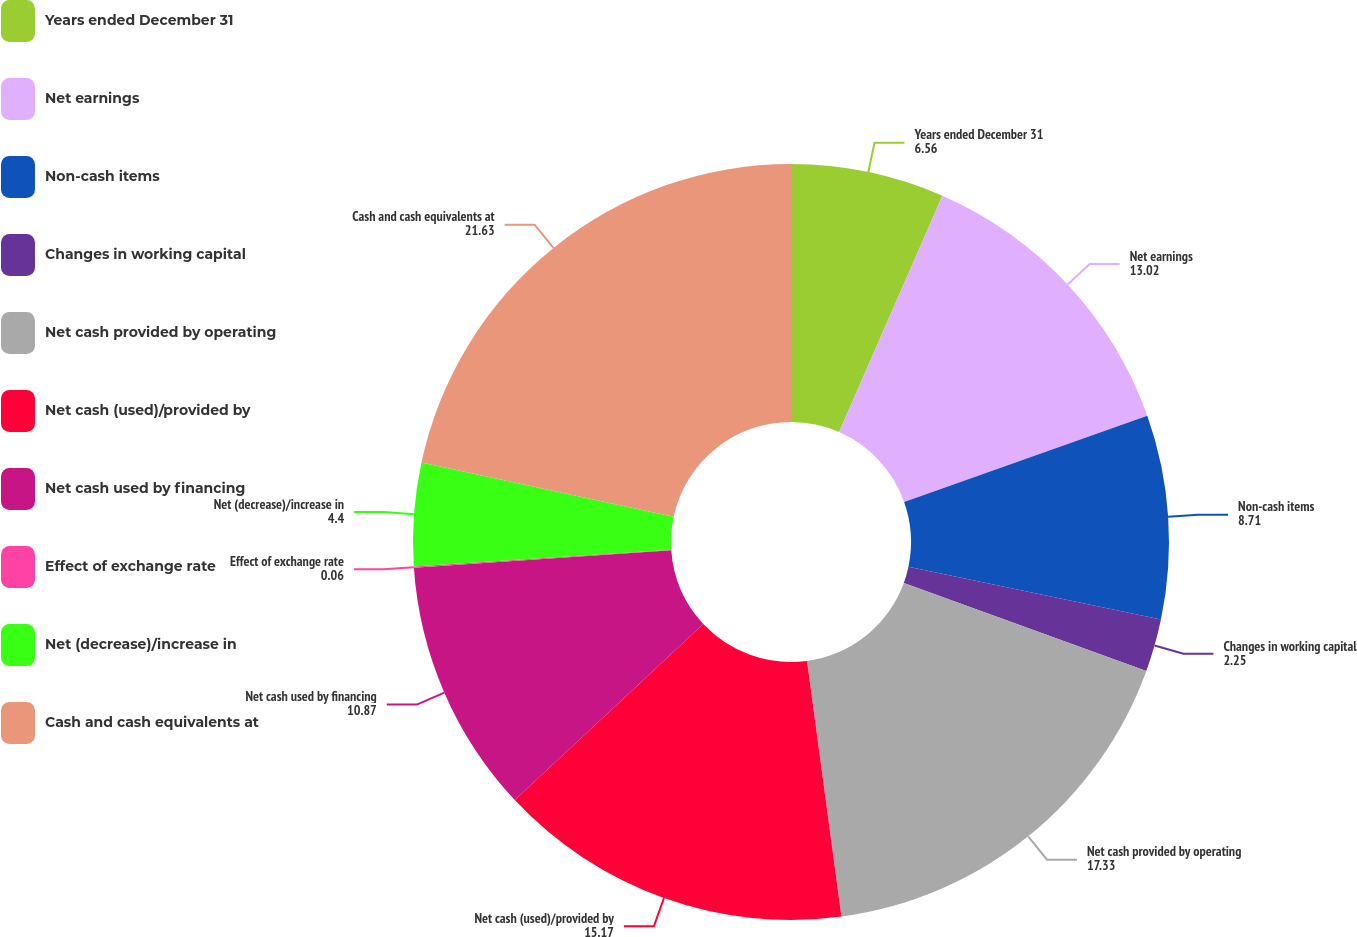<chart> <loc_0><loc_0><loc_500><loc_500><pie_chart><fcel>Years ended December 31<fcel>Net earnings<fcel>Non-cash items<fcel>Changes in working capital<fcel>Net cash provided by operating<fcel>Net cash (used)/provided by<fcel>Net cash used by financing<fcel>Effect of exchange rate<fcel>Net (decrease)/increase in<fcel>Cash and cash equivalents at<nl><fcel>6.56%<fcel>13.02%<fcel>8.71%<fcel>2.25%<fcel>17.33%<fcel>15.17%<fcel>10.87%<fcel>0.06%<fcel>4.4%<fcel>21.63%<nl></chart> 